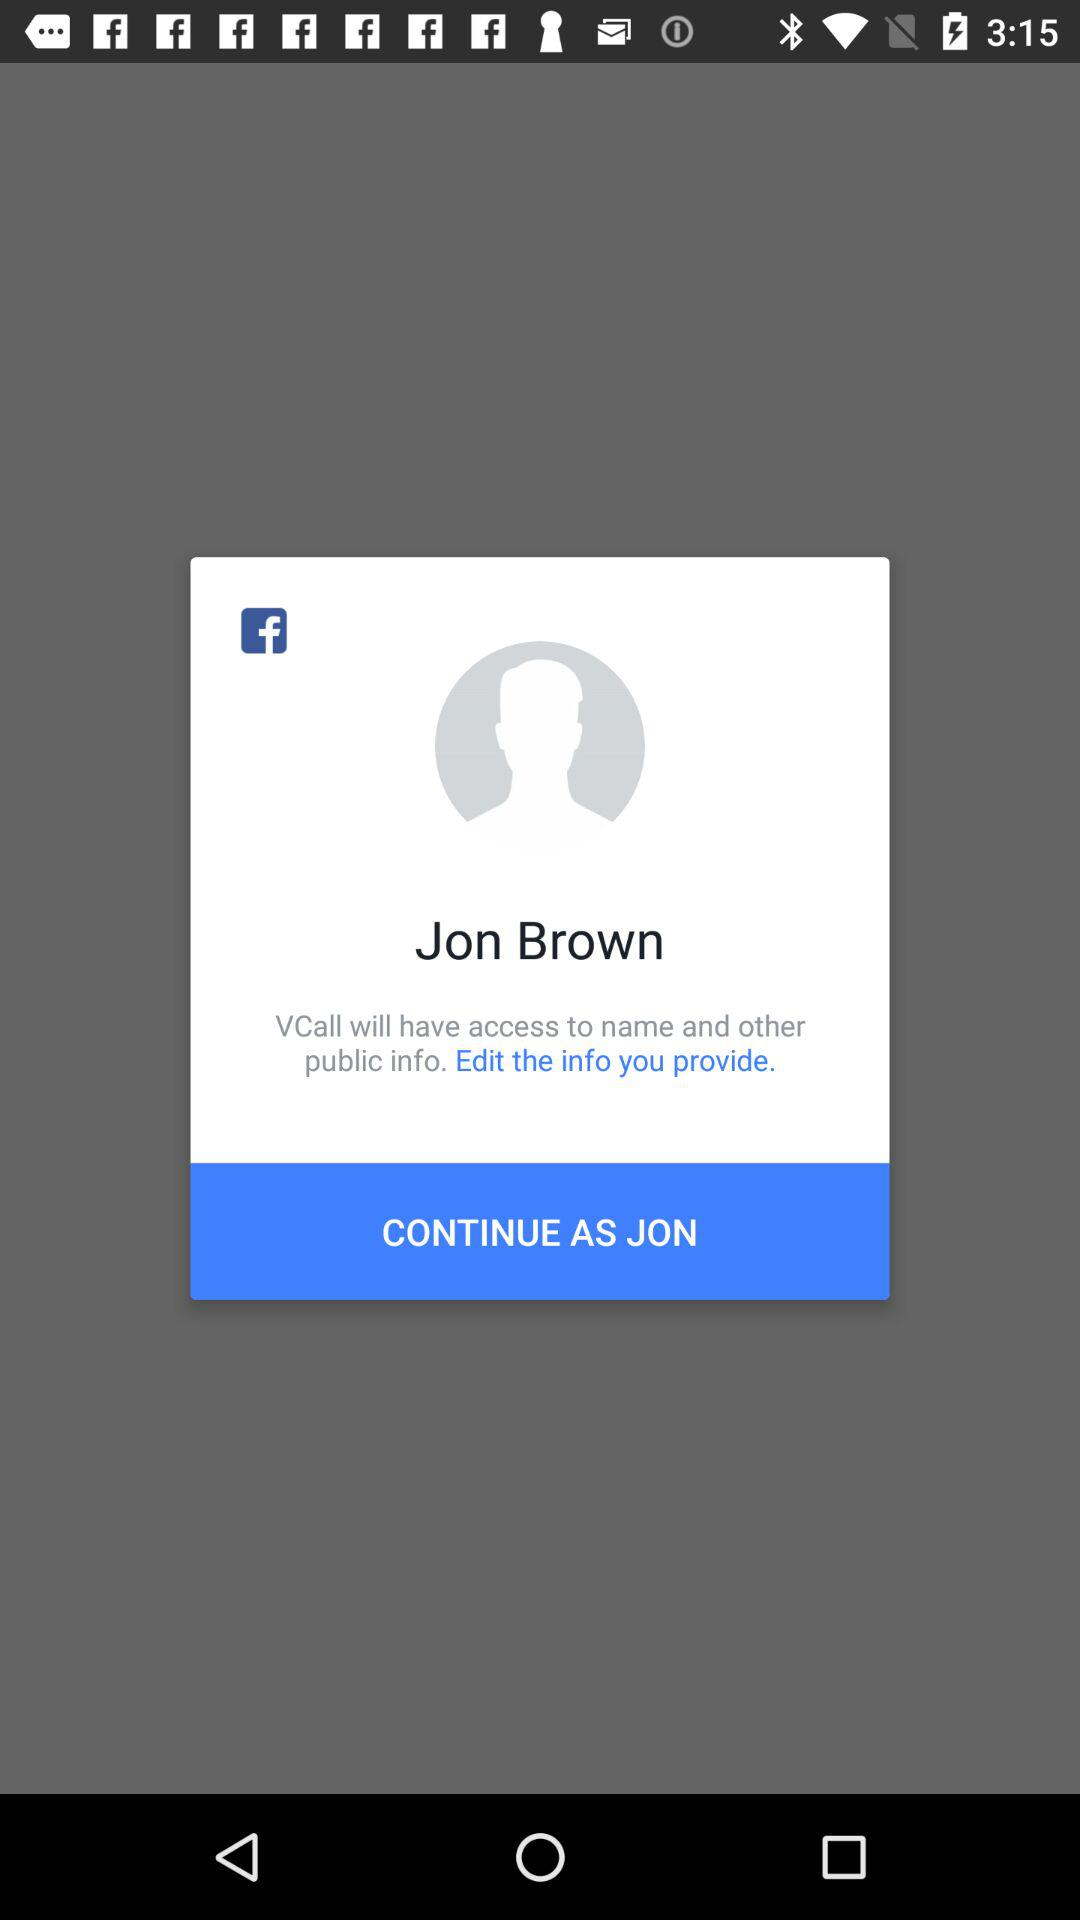What is the user name? The user name is Jon Brown. 